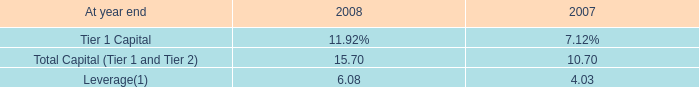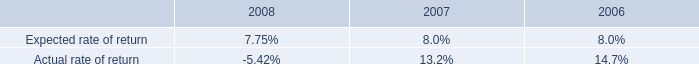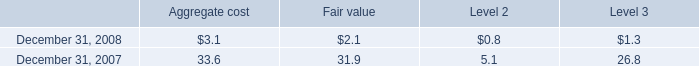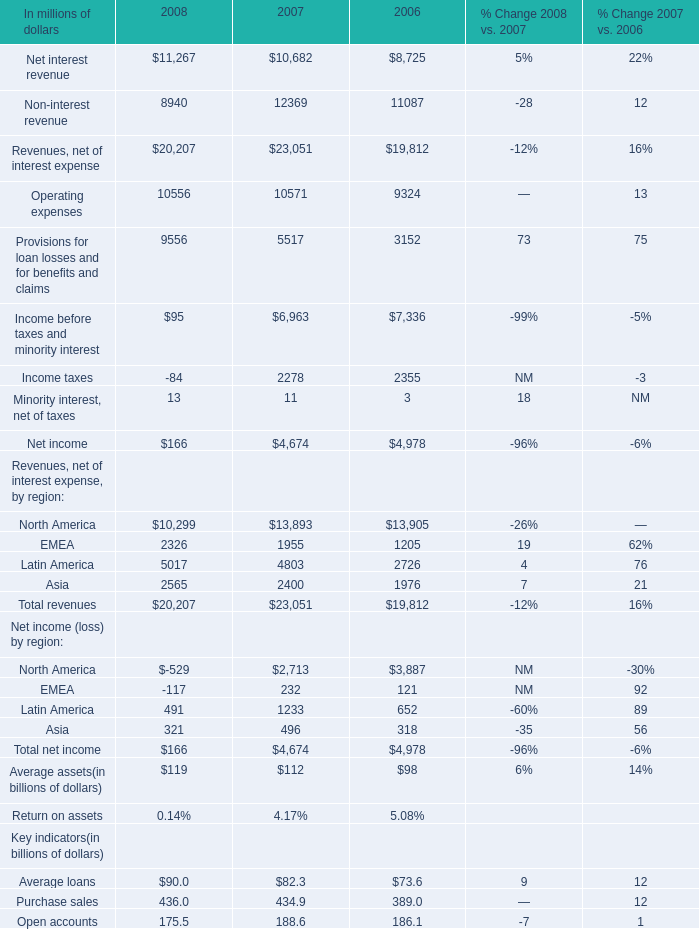What is the growing rate of Total revenue for Revenues, net of interest expense, by region in the years with the least Net income (loss) by region For EMEA? 
Computations: ((20207 - 23051) / 23051)
Answer: -0.12338. 